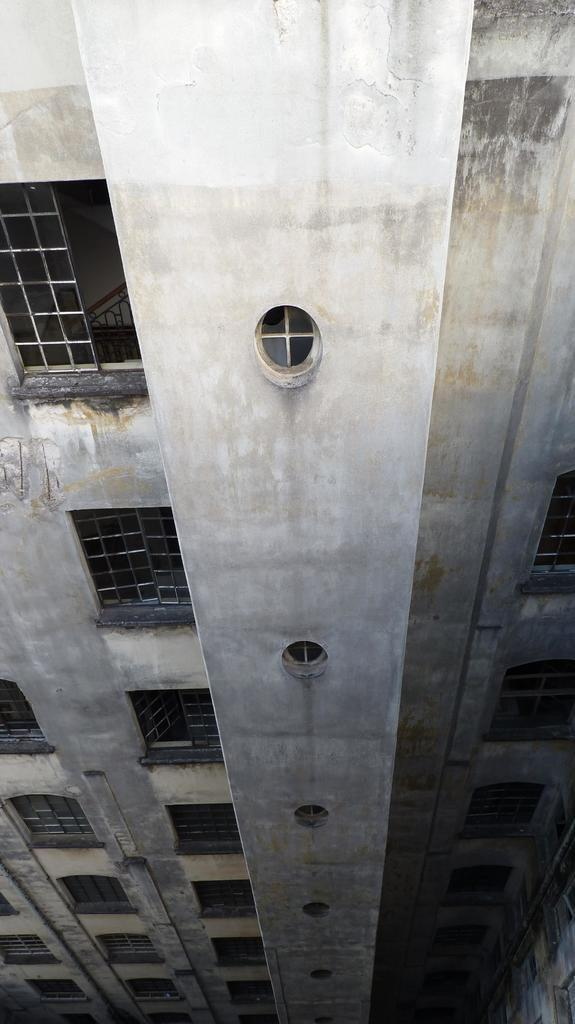What type of structure can be seen in the image? There is a building in the image. What material is used for the rods in the image? The rods in the image are made of metal. How many hens are sitting on the metal rods in the image? There are no hens present in the image; it only features a building and metal rods. 